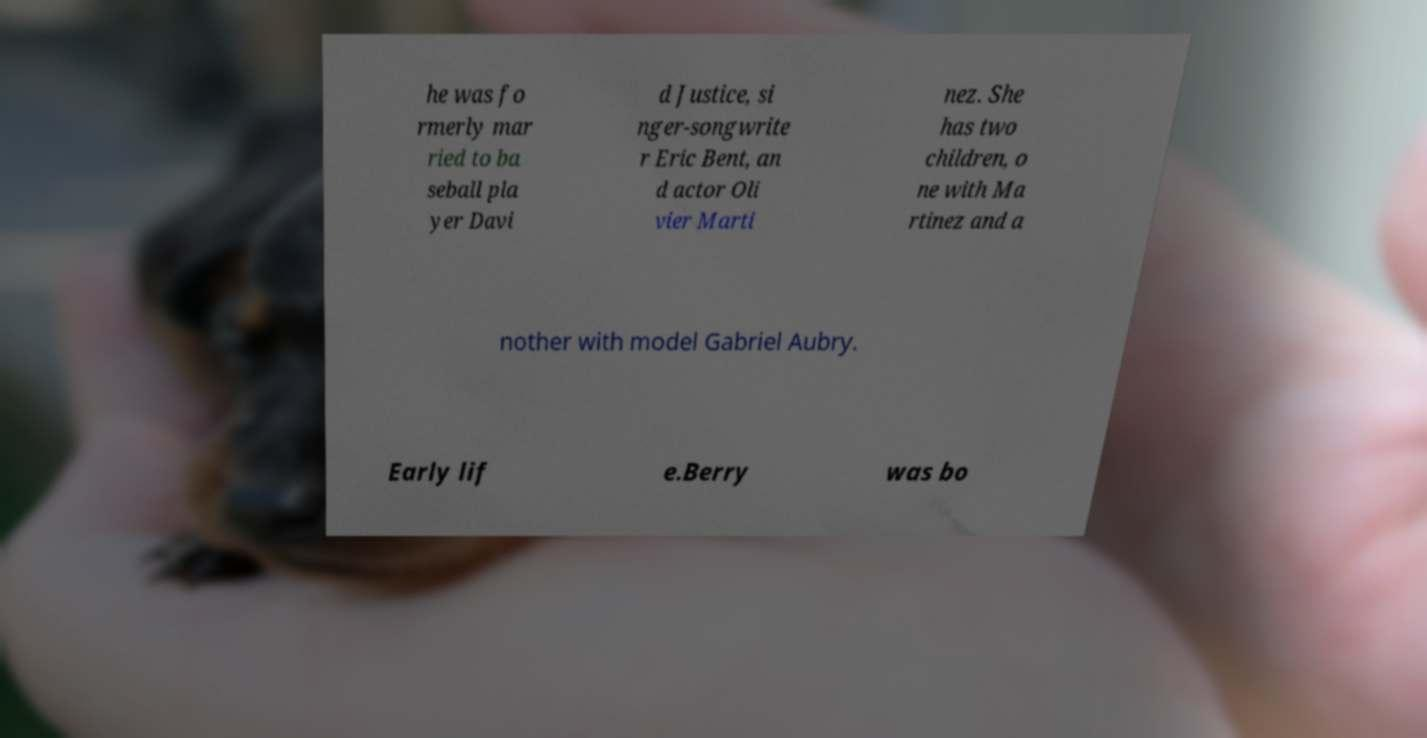Please identify and transcribe the text found in this image. he was fo rmerly mar ried to ba seball pla yer Davi d Justice, si nger-songwrite r Eric Bent, an d actor Oli vier Marti nez. She has two children, o ne with Ma rtinez and a nother with model Gabriel Aubry. Early lif e.Berry was bo 